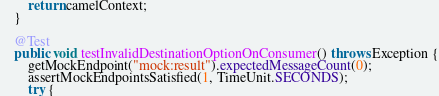Convert code to text. <code><loc_0><loc_0><loc_500><loc_500><_Java_>
        return camelContext;
    }

    @Test
    public void testInvalidDestinationOptionOnConsumer() throws Exception {
        getMockEndpoint("mock:result").expectedMessageCount(0);
        assertMockEndpointsSatisfied(1, TimeUnit.SECONDS);
        try {</code> 